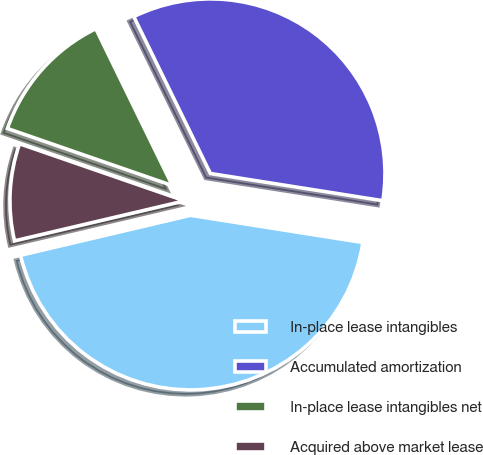<chart> <loc_0><loc_0><loc_500><loc_500><pie_chart><fcel>In-place lease intangibles<fcel>Accumulated amortization<fcel>In-place lease intangibles net<fcel>Acquired above market lease<nl><fcel>43.83%<fcel>34.72%<fcel>12.47%<fcel>8.98%<nl></chart> 